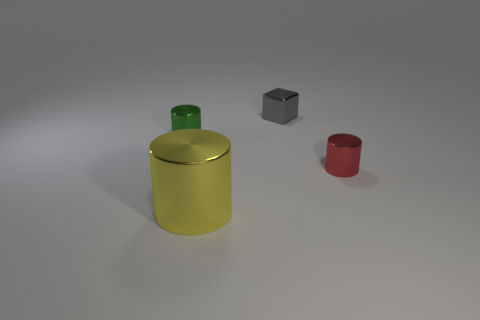Subtract all tiny green cylinders. How many cylinders are left? 2 Add 1 shiny cylinders. How many objects exist? 5 Subtract all green cylinders. How many cylinders are left? 2 Subtract 1 cylinders. How many cylinders are left? 2 Subtract all blocks. How many objects are left? 3 Subtract all brown cylinders. How many purple blocks are left? 0 Subtract all blue matte things. Subtract all tiny shiny cubes. How many objects are left? 3 Add 3 tiny red shiny cylinders. How many tiny red shiny cylinders are left? 4 Add 3 small blocks. How many small blocks exist? 4 Subtract 0 green blocks. How many objects are left? 4 